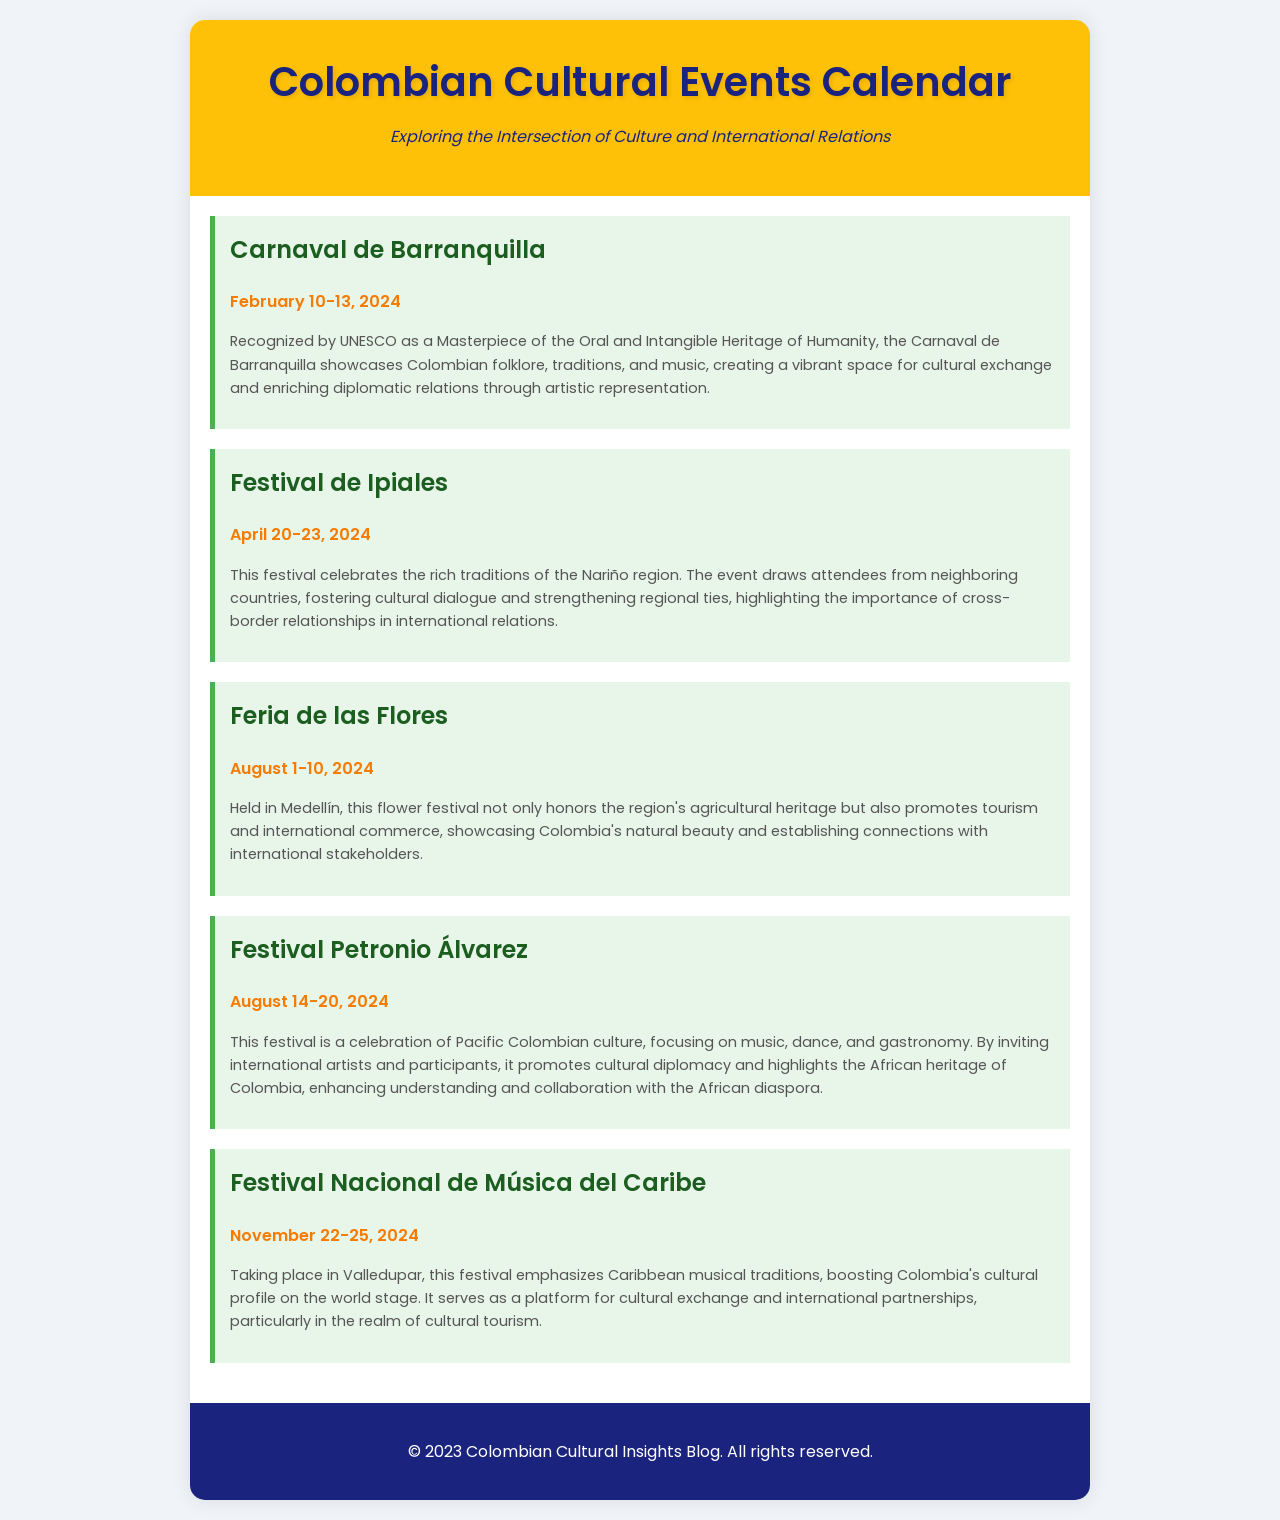What is the date range for the Carnaval de Barranquilla? The event is scheduled from February 10 to February 13 in 2024.
Answer: February 10-13, 2024 What is the significance of the Feria de las Flores? It promotes tourism and international commerce while showcasing Colombia's natural beauty.
Answer: Promotes tourism and international commerce In what city is the Festival Petronio Álvarez held? The festival takes place in a city known for its celebration of Pacific Colombian culture.
Answer: Cali What cultural aspect does the Festival Nacional de Música del Caribe emphasize? The festival emphasizes musical traditions from the Caribbean region.
Answer: Caribbean musical traditions Which event is recognized by UNESCO? The Carnaval de Barranquilla has been recognized for its cultural heritage significance.
Answer: Carnaval de Barranquilla How many days does the Festival de Ipiales last? The festival spans over a few days in April, specified in the schedule.
Answer: 4 days What type of international relations does the Carnaval de Barranquilla enhance? The event enriches diplomatic relations through artistic representation.
Answer: Artistic representation Which festival highlights the African heritage of Colombia? The Festival Petronio Álvarez focuses on this cultural aspect.
Answer: Festival Petronio Álvarez What is the purpose of fostering cultural dialogue at the Festival de Ipiales? It aims to strengthen regional ties and cross-border relationships.
Answer: Strengthening regional ties 